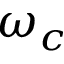Convert formula to latex. <formula><loc_0><loc_0><loc_500><loc_500>\omega _ { c }</formula> 